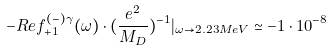<formula> <loc_0><loc_0><loc_500><loc_500>- R e f ^ { ( - ) \gamma } _ { + 1 } ( \omega ) \cdot ( \frac { e ^ { 2 } } { M _ { D } } ) ^ { - 1 } | _ { \omega \rightarrow 2 . 2 3 M e V } \simeq - 1 \cdot 1 0 ^ { - 8 }</formula> 